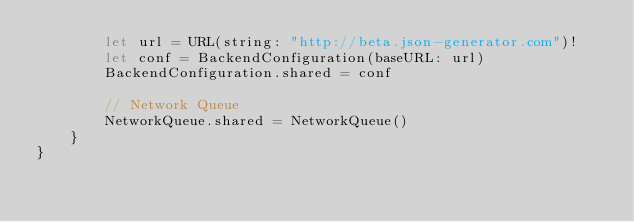Convert code to text. <code><loc_0><loc_0><loc_500><loc_500><_Swift_>        let url = URL(string: "http://beta.json-generator.com")!
        let conf = BackendConfiguration(baseURL: url)
        BackendConfiguration.shared = conf
        
        // Network Queue
        NetworkQueue.shared = NetworkQueue()
    }
}
</code> 